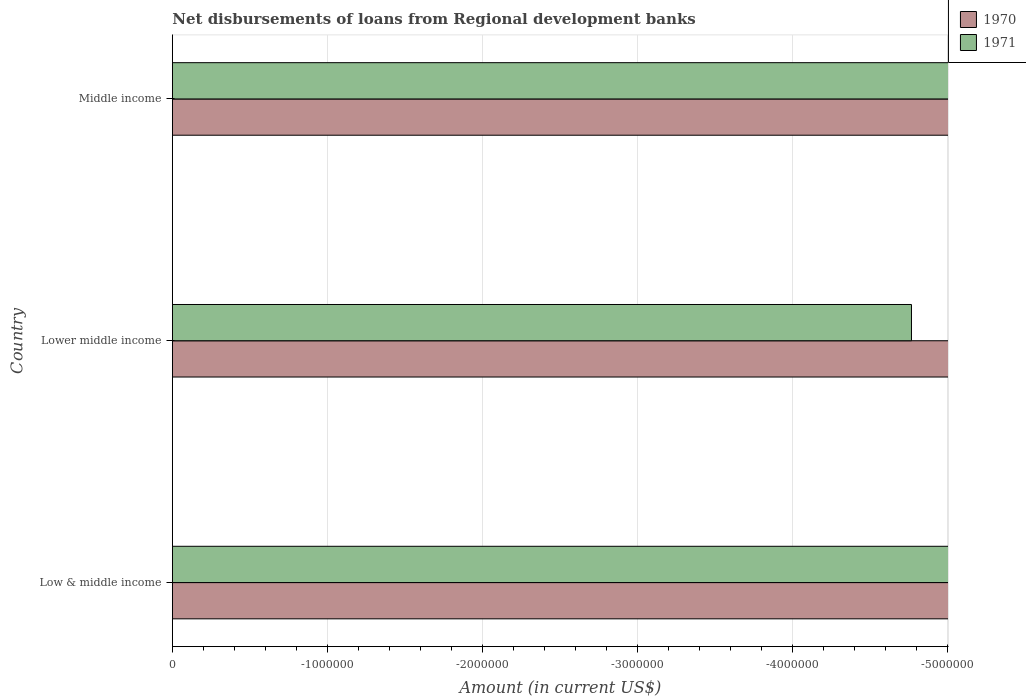Are the number of bars per tick equal to the number of legend labels?
Provide a short and direct response. No. Are the number of bars on each tick of the Y-axis equal?
Keep it short and to the point. Yes. What is the label of the 1st group of bars from the top?
Offer a very short reply. Middle income. What is the average amount of disbursements of loans from regional development banks in 1971 per country?
Your response must be concise. 0. In how many countries, is the amount of disbursements of loans from regional development banks in 1970 greater than the average amount of disbursements of loans from regional development banks in 1970 taken over all countries?
Offer a very short reply. 0. How many countries are there in the graph?
Give a very brief answer. 3. What is the difference between two consecutive major ticks on the X-axis?
Your response must be concise. 1.00e+06. How many legend labels are there?
Your answer should be compact. 2. How are the legend labels stacked?
Provide a short and direct response. Vertical. What is the title of the graph?
Your answer should be very brief. Net disbursements of loans from Regional development banks. What is the label or title of the X-axis?
Your answer should be very brief. Amount (in current US$). What is the label or title of the Y-axis?
Ensure brevity in your answer.  Country. What is the Amount (in current US$) of 1970 in Low & middle income?
Offer a terse response. 0. What is the Amount (in current US$) in 1970 in Lower middle income?
Give a very brief answer. 0. What is the Amount (in current US$) in 1970 in Middle income?
Provide a short and direct response. 0. What is the total Amount (in current US$) of 1970 in the graph?
Provide a succinct answer. 0. What is the total Amount (in current US$) of 1971 in the graph?
Your answer should be very brief. 0. What is the average Amount (in current US$) in 1970 per country?
Offer a very short reply. 0. What is the average Amount (in current US$) of 1971 per country?
Offer a very short reply. 0. 